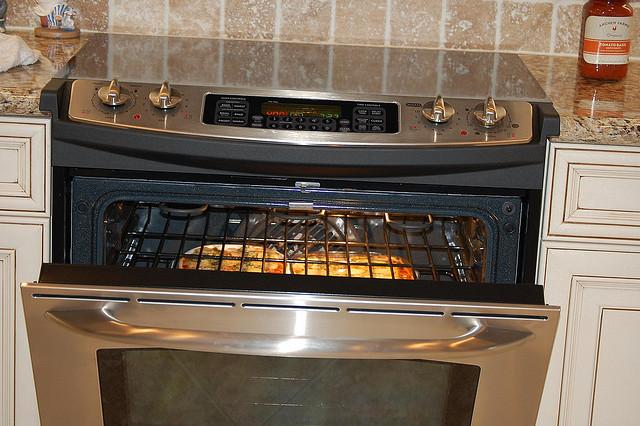Is this a kitchen?
Quick response, please. Yes. Is the oven open?
Quick response, please. Yes. What kind of food is in the jar on the counter?
Answer briefly. Pizza. 